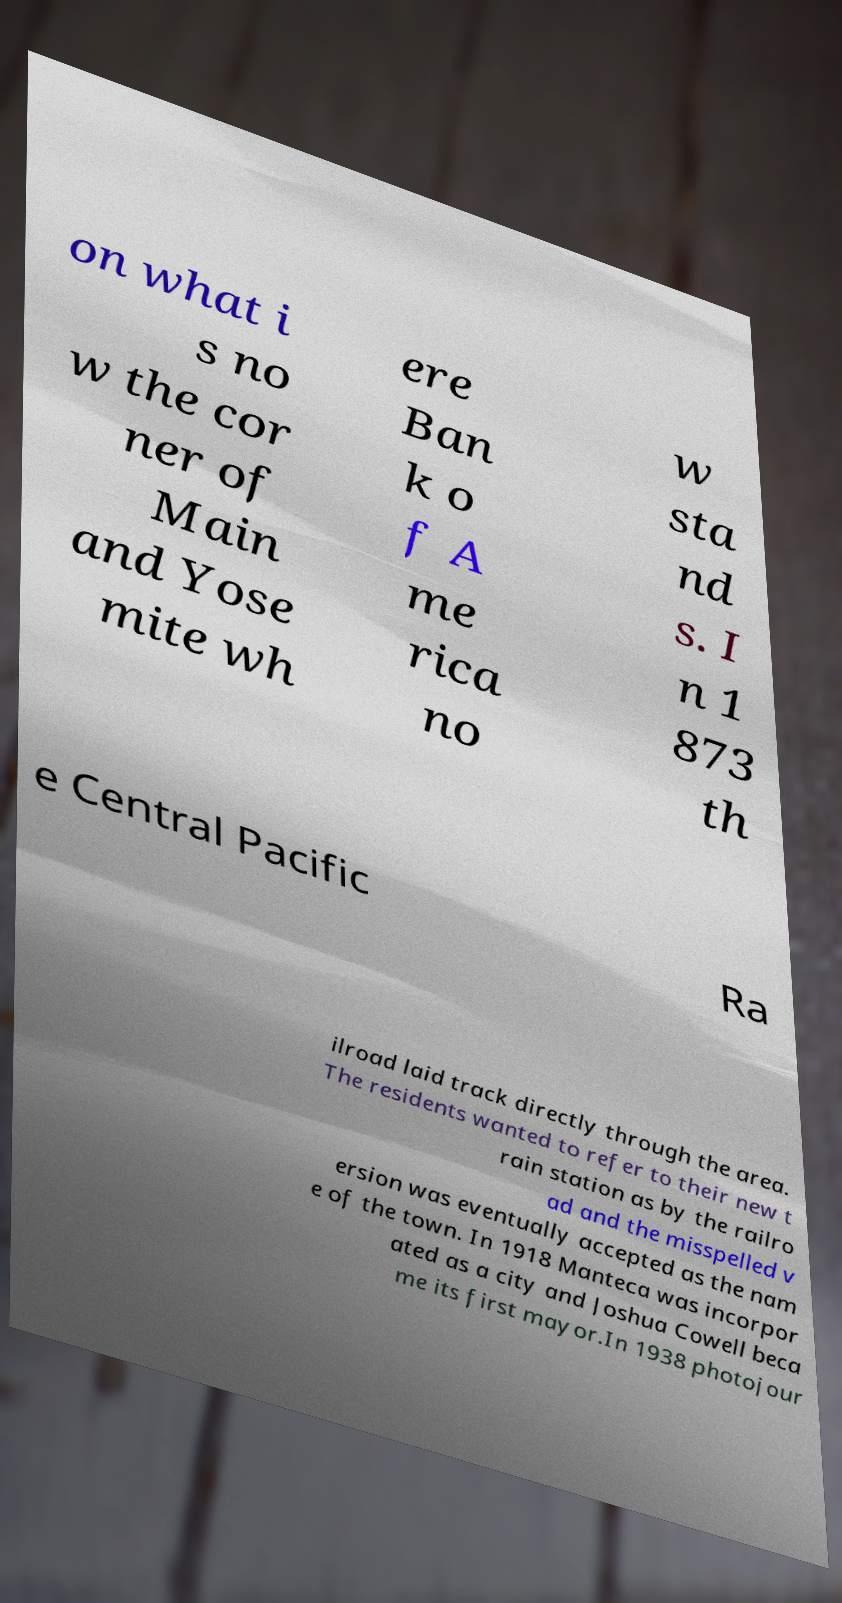Can you accurately transcribe the text from the provided image for me? on what i s no w the cor ner of Main and Yose mite wh ere Ban k o f A me rica no w sta nd s. I n 1 873 th e Central Pacific Ra ilroad laid track directly through the area. The residents wanted to refer to their new t rain station as by the railro ad and the misspelled v ersion was eventually accepted as the nam e of the town. In 1918 Manteca was incorpor ated as a city and Joshua Cowell beca me its first mayor.In 1938 photojour 